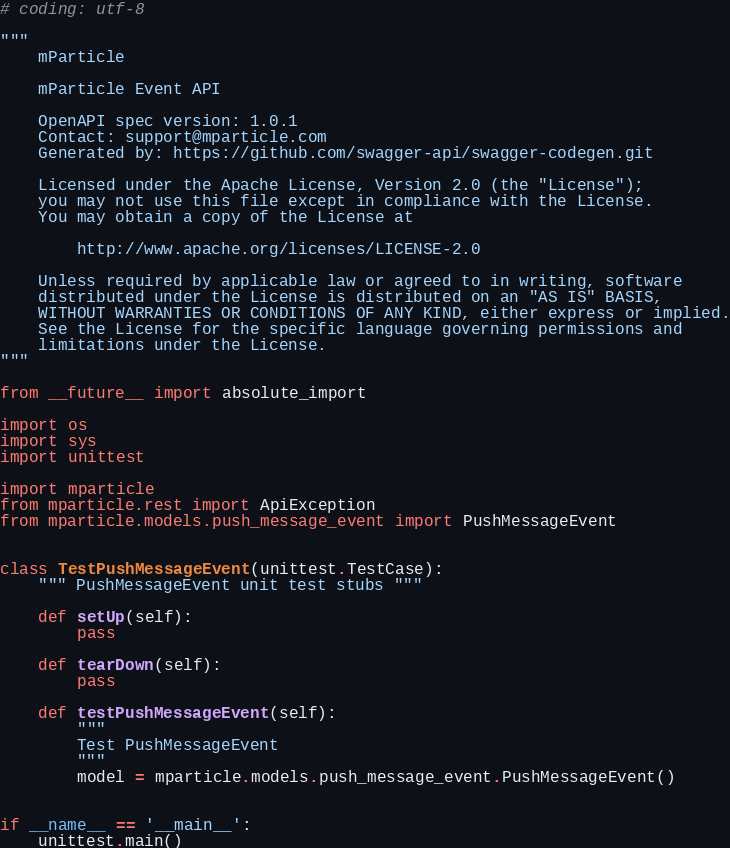<code> <loc_0><loc_0><loc_500><loc_500><_Python_># coding: utf-8

"""
    mParticle

    mParticle Event API

    OpenAPI spec version: 1.0.1
    Contact: support@mparticle.com
    Generated by: https://github.com/swagger-api/swagger-codegen.git

    Licensed under the Apache License, Version 2.0 (the "License");
    you may not use this file except in compliance with the License.
    You may obtain a copy of the License at

        http://www.apache.org/licenses/LICENSE-2.0

    Unless required by applicable law or agreed to in writing, software
    distributed under the License is distributed on an "AS IS" BASIS,
    WITHOUT WARRANTIES OR CONDITIONS OF ANY KIND, either express or implied.
    See the License for the specific language governing permissions and
    limitations under the License.
"""

from __future__ import absolute_import

import os
import sys
import unittest

import mparticle
from mparticle.rest import ApiException
from mparticle.models.push_message_event import PushMessageEvent


class TestPushMessageEvent(unittest.TestCase):
    """ PushMessageEvent unit test stubs """

    def setUp(self):
        pass

    def tearDown(self):
        pass

    def testPushMessageEvent(self):
        """
        Test PushMessageEvent
        """
        model = mparticle.models.push_message_event.PushMessageEvent()


if __name__ == '__main__':
    unittest.main()
</code> 